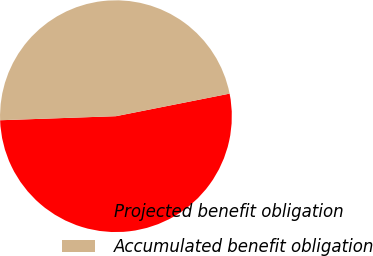<chart> <loc_0><loc_0><loc_500><loc_500><pie_chart><fcel>Projected benefit obligation<fcel>Accumulated benefit obligation<nl><fcel>52.56%<fcel>47.44%<nl></chart> 